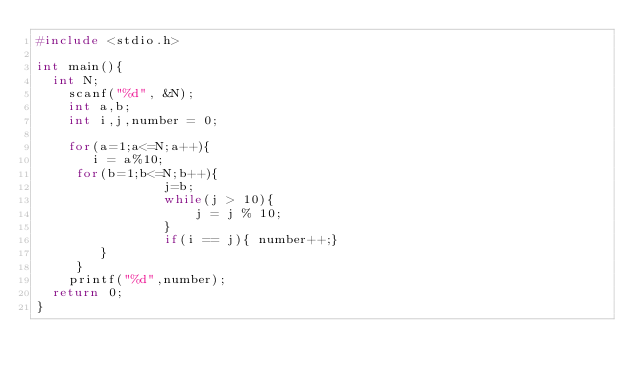<code> <loc_0><loc_0><loc_500><loc_500><_C_>#include <stdio.h>

int main(){
	int N;
  	scanf("%d", &N);
  	int a,b;
  	int i,j,number = 0;
  	
  	for(a=1;a<=N;a++){
       i = a%10;
	   for(b=1;b<=N;b++){
               	j=b;
                while(j > 10){
                    j = j % 10;
                }
                if(i == j){ number++;}
        }
     }
  	printf("%d",number);
	return 0;
}
</code> 